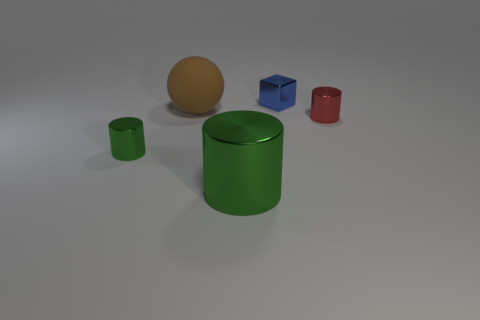What is the shape of the blue thing? The blue object is a cube with a shiny surface reflecting light, distinguishing its perfectly equal edges and angles. 